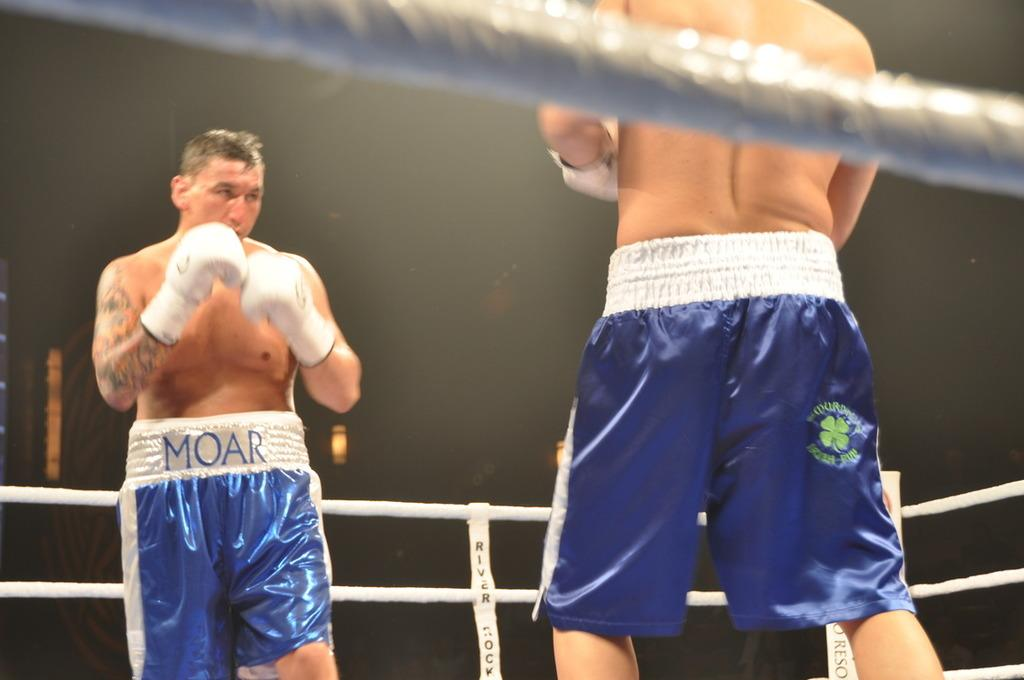What activity are the two individuals in the image engaged in? The two individuals in the image are boxing. What can be seen in the background of the image? There is a stage in the image, and fencing around the stage. What color are the shorts worn by both boxers? Both boxers are wearing blue shorts. What type of gloves are the boxers wearing? Both boxers are wearing white gloves. What type of paper can be seen on the sofa in the image? There is no sofa or paper present in the image; it features two boxers on a stage with fencing around it. 